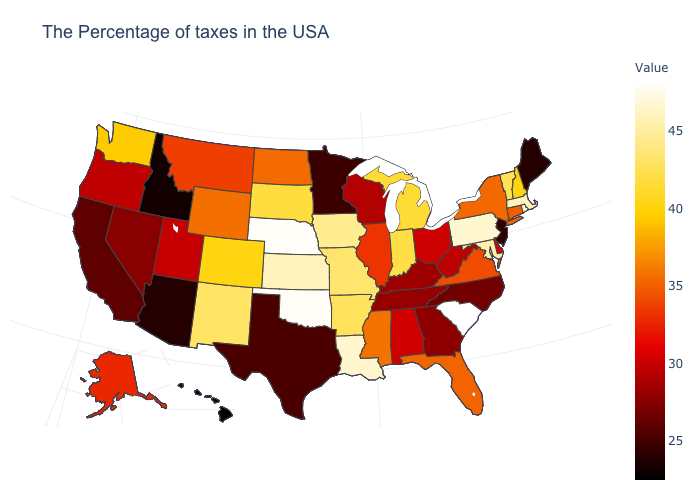Which states hav the highest value in the Northeast?
Answer briefly. Pennsylvania. Does New Mexico have the highest value in the West?
Concise answer only. Yes. Among the states that border Alabama , does Mississippi have the highest value?
Give a very brief answer. Yes. Which states have the lowest value in the USA?
Short answer required. Hawaii. 